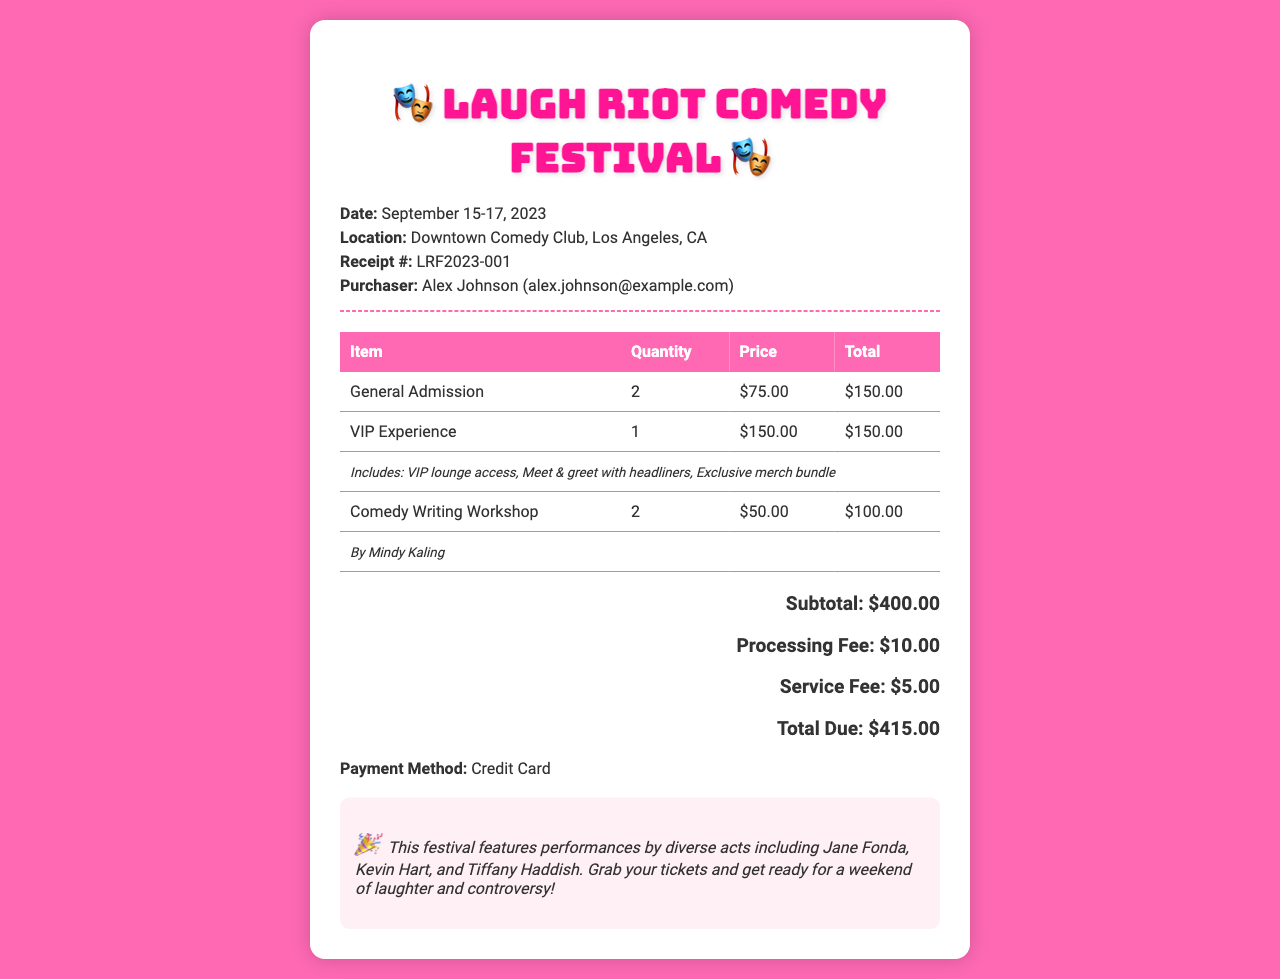What is the date of the festival? The date of the festival is explicitly mentioned in the document as September 15-17, 2023.
Answer: September 15-17, 2023 Who is the purchaser? The purchaser's name is provided in the document, listed as Alex Johnson.
Answer: Alex Johnson How many general admission tickets were purchased? The quantity of general admission tickets is stated in the table as 2.
Answer: 2 What is the total due amount? The document specifies the total due amount at the end, which includes all fees and charges.
Answer: $415.00 What is included in the VIP experience? The document mentions inclusions like VIP lounge access, Meet & greet with headliners, and Exclusive merch bundle.
Answer: VIP lounge access, Meet & greet with headliners, Exclusive merch bundle Who is leading the comedy writing workshop? The document states that the comedy writing workshop is by Mindy Kaling.
Answer: Mindy Kaling How much is the processing fee? The processing fee is specifically listed in the document as $10.00.
Answer: $10.00 What type of performances does the festival feature? The document highlights that the festival features performances by diverse acts, indicating a range of genres and styles.
Answer: Diverse acts How many comedy writing workshops were purchased? The quantity of comedy writing workshops is noted in the table as 2.
Answer: 2 